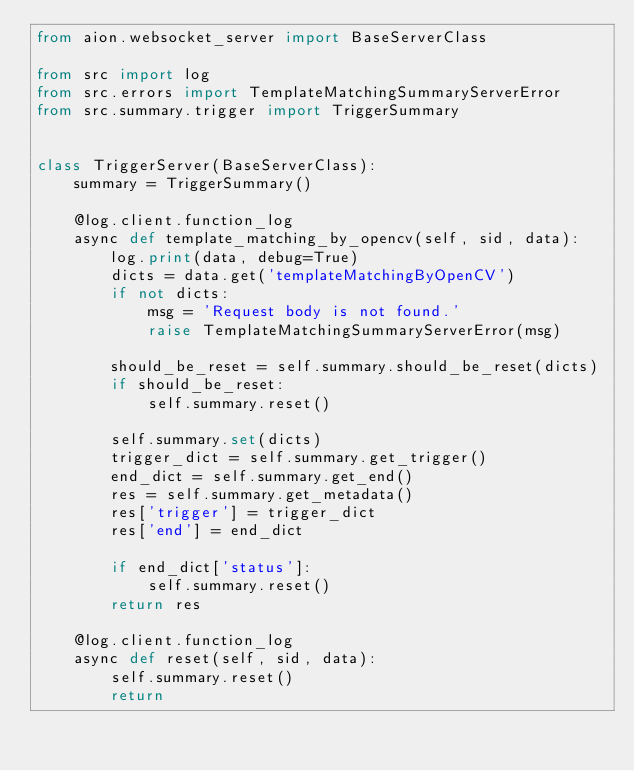Convert code to text. <code><loc_0><loc_0><loc_500><loc_500><_Python_>from aion.websocket_server import BaseServerClass

from src import log
from src.errors import TemplateMatchingSummaryServerError
from src.summary.trigger import TriggerSummary


class TriggerServer(BaseServerClass):
    summary = TriggerSummary()

    @log.client.function_log
    async def template_matching_by_opencv(self, sid, data):
        log.print(data, debug=True)
        dicts = data.get('templateMatchingByOpenCV')
        if not dicts:
            msg = 'Request body is not found.'
            raise TemplateMatchingSummaryServerError(msg)

        should_be_reset = self.summary.should_be_reset(dicts)
        if should_be_reset:
            self.summary.reset()

        self.summary.set(dicts)
        trigger_dict = self.summary.get_trigger()
        end_dict = self.summary.get_end()
        res = self.summary.get_metadata()
        res['trigger'] = trigger_dict
        res['end'] = end_dict

        if end_dict['status']:
            self.summary.reset()
        return res

    @log.client.function_log
    async def reset(self, sid, data):
        self.summary.reset()
        return
</code> 